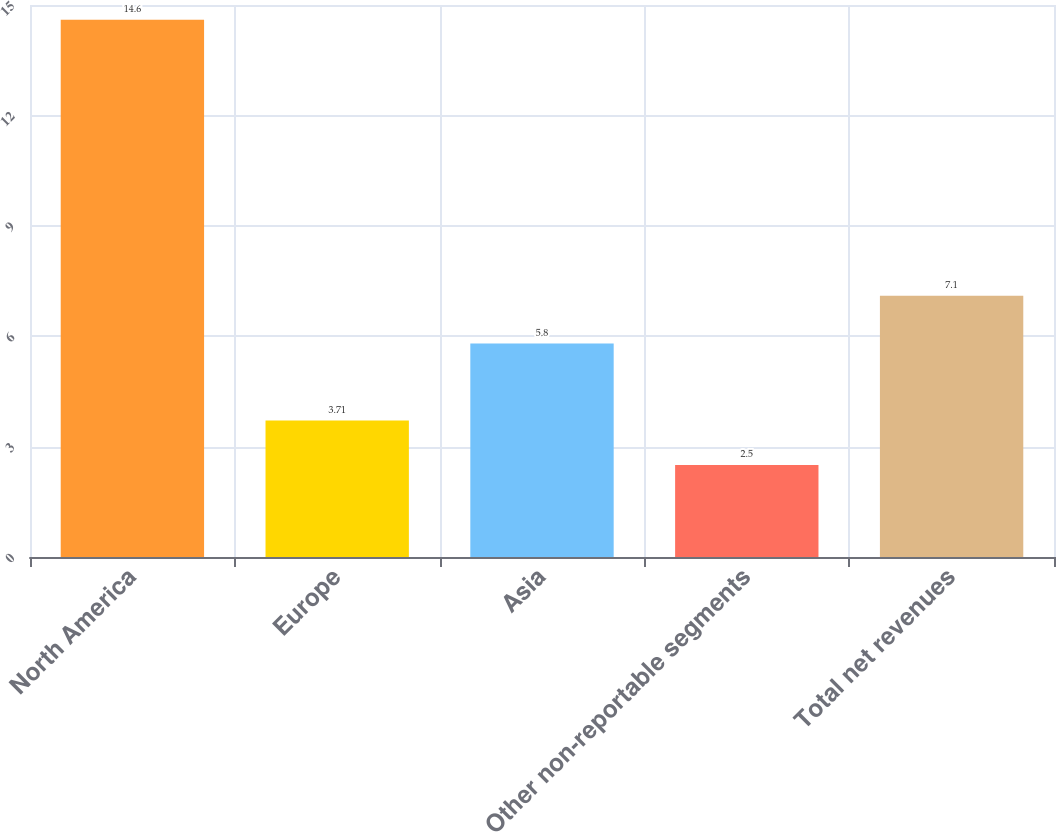Convert chart to OTSL. <chart><loc_0><loc_0><loc_500><loc_500><bar_chart><fcel>North America<fcel>Europe<fcel>Asia<fcel>Other non-reportable segments<fcel>Total net revenues<nl><fcel>14.6<fcel>3.71<fcel>5.8<fcel>2.5<fcel>7.1<nl></chart> 